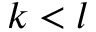<formula> <loc_0><loc_0><loc_500><loc_500>k < l</formula> 